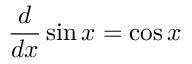<formula> <loc_0><loc_0><loc_500><loc_500>{ \frac { d } { d x } } \sin x = \cos x</formula> 